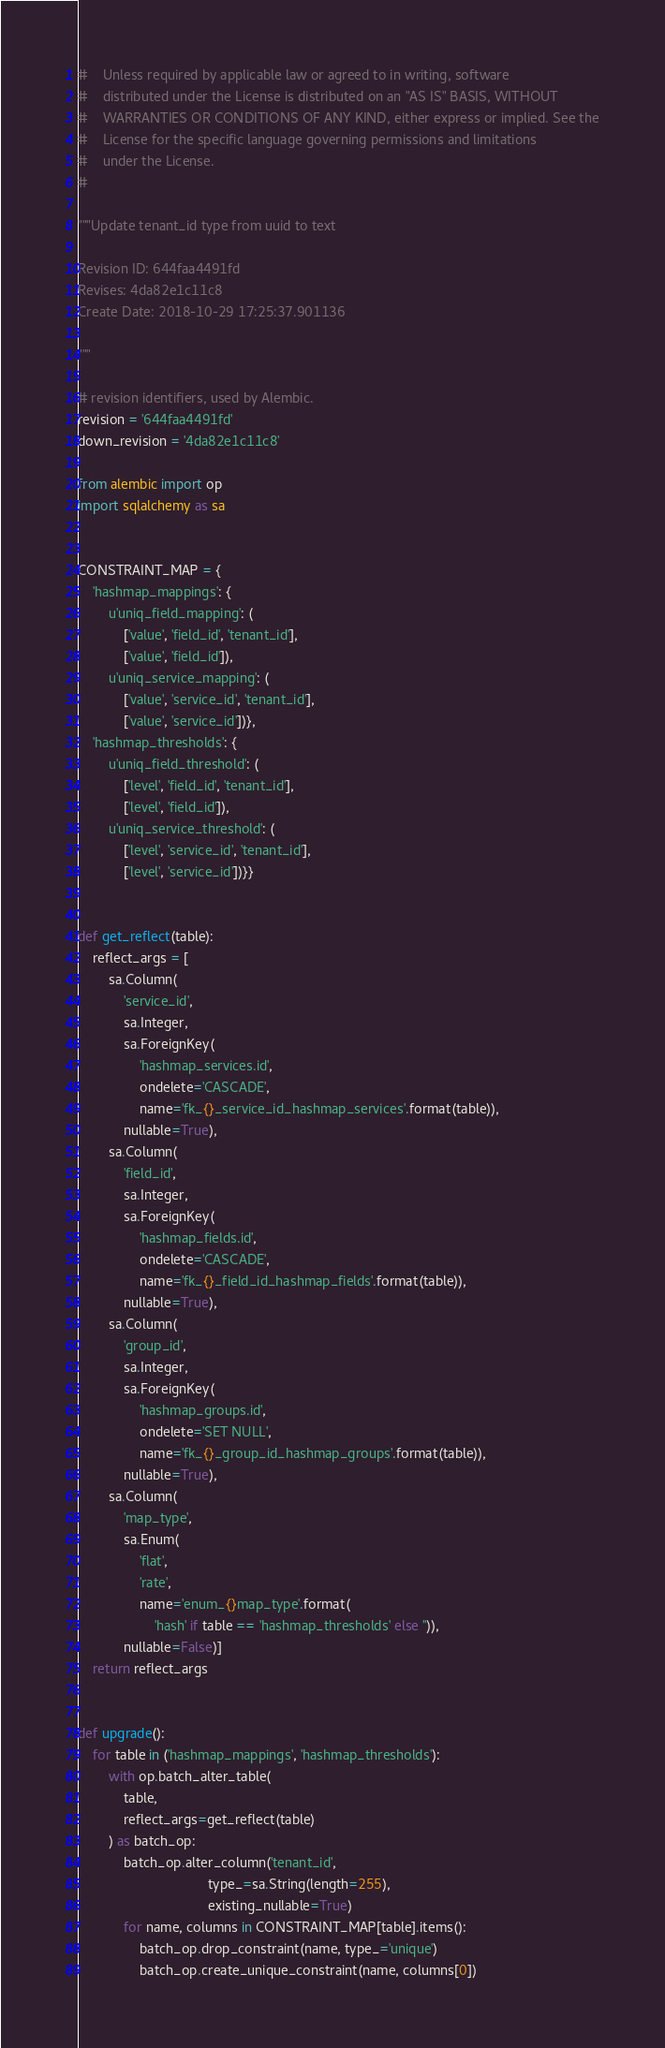<code> <loc_0><loc_0><loc_500><loc_500><_Python_>#    Unless required by applicable law or agreed to in writing, software
#    distributed under the License is distributed on an "AS IS" BASIS, WITHOUT
#    WARRANTIES OR CONDITIONS OF ANY KIND, either express or implied. See the
#    License for the specific language governing permissions and limitations
#    under the License.
#

"""Update tenant_id type from uuid to text

Revision ID: 644faa4491fd
Revises: 4da82e1c11c8
Create Date: 2018-10-29 17:25:37.901136

"""

# revision identifiers, used by Alembic.
revision = '644faa4491fd'
down_revision = '4da82e1c11c8'

from alembic import op
import sqlalchemy as sa


CONSTRAINT_MAP = {
    'hashmap_mappings': {
        u'uniq_field_mapping': (
            ['value', 'field_id', 'tenant_id'],
            ['value', 'field_id']),
        u'uniq_service_mapping': (
            ['value', 'service_id', 'tenant_id'],
            ['value', 'service_id'])},
    'hashmap_thresholds': {
        u'uniq_field_threshold': (
            ['level', 'field_id', 'tenant_id'],
            ['level', 'field_id']),
        u'uniq_service_threshold': (
            ['level', 'service_id', 'tenant_id'],
            ['level', 'service_id'])}}


def get_reflect(table):
    reflect_args = [
        sa.Column(
            'service_id',
            sa.Integer,
            sa.ForeignKey(
                'hashmap_services.id',
                ondelete='CASCADE',
                name='fk_{}_service_id_hashmap_services'.format(table)),
            nullable=True),
        sa.Column(
            'field_id',
            sa.Integer,
            sa.ForeignKey(
                'hashmap_fields.id',
                ondelete='CASCADE',
                name='fk_{}_field_id_hashmap_fields'.format(table)),
            nullable=True),
        sa.Column(
            'group_id',
            sa.Integer,
            sa.ForeignKey(
                'hashmap_groups.id',
                ondelete='SET NULL',
                name='fk_{}_group_id_hashmap_groups'.format(table)),
            nullable=True),
        sa.Column(
            'map_type',
            sa.Enum(
                'flat',
                'rate',
                name='enum_{}map_type'.format(
                    'hash' if table == 'hashmap_thresholds' else '')),
            nullable=False)]
    return reflect_args


def upgrade():
    for table in ('hashmap_mappings', 'hashmap_thresholds'):
        with op.batch_alter_table(
            table,
            reflect_args=get_reflect(table)
        ) as batch_op:
            batch_op.alter_column('tenant_id',
                                  type_=sa.String(length=255),
                                  existing_nullable=True)
            for name, columns in CONSTRAINT_MAP[table].items():
                batch_op.drop_constraint(name, type_='unique')
                batch_op.create_unique_constraint(name, columns[0])
</code> 